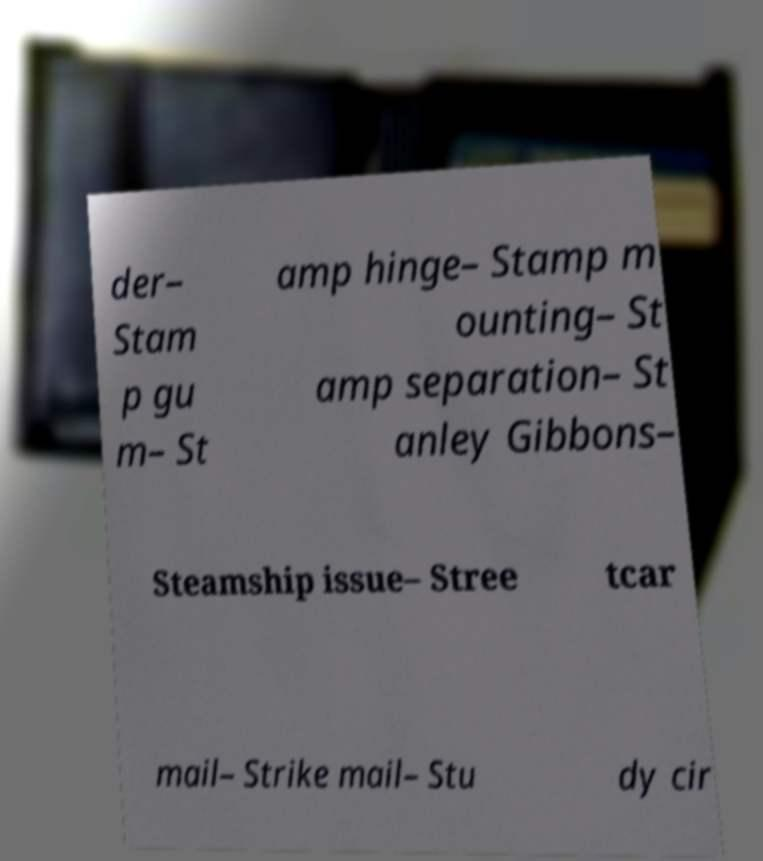Could you assist in decoding the text presented in this image and type it out clearly? der– Stam p gu m– St amp hinge– Stamp m ounting– St amp separation– St anley Gibbons– Steamship issue– Stree tcar mail– Strike mail– Stu dy cir 